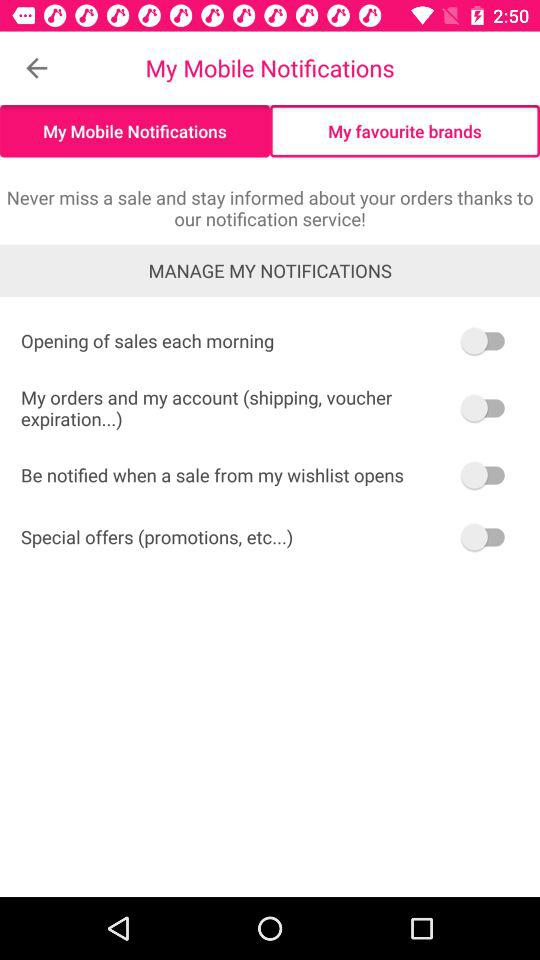What is the status of "Opening of sales each morning"? The status is "off". 